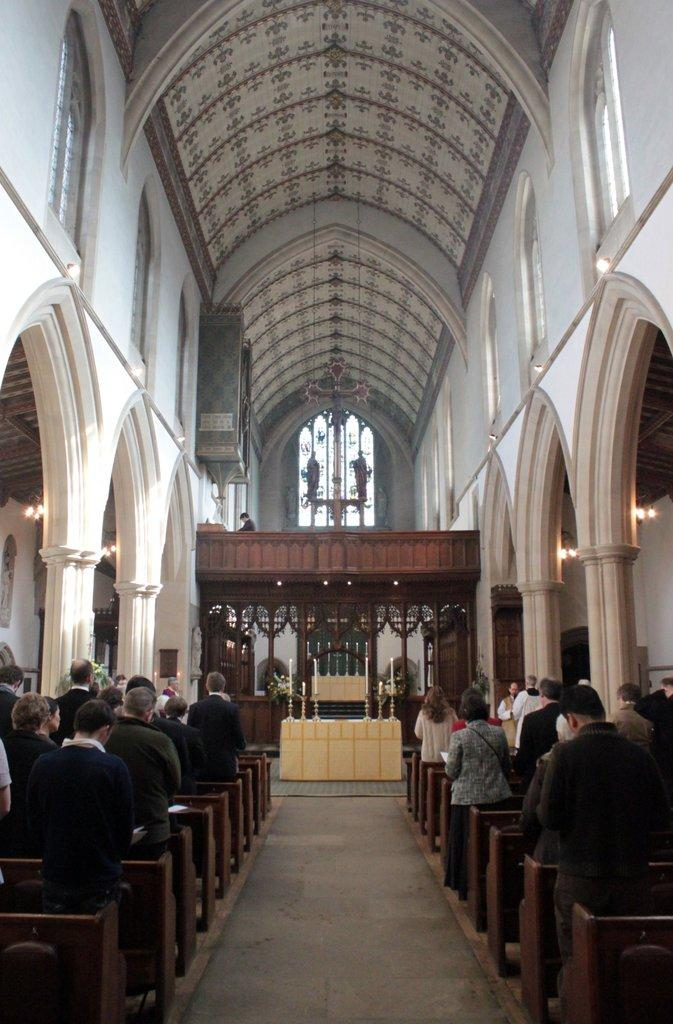What type of building is the image taken in? The image is taken in a church. Are there any people present in the image? Yes, there are people standing in the image. What is the main feature in the center of the image? There is an alter in the center of the image. What type of lighting is present in the image? Candles are visible in the image. What can be seen above the people in the image? There is a roof in the image. What architectural elements support the roof in the image? Pillars are present in the image. What type of metal is used to make the neck of the person in the image? There is no mention of a neck or any metal in the image, as it focuses on the church, people, alter, candles, roof, and pillars. 